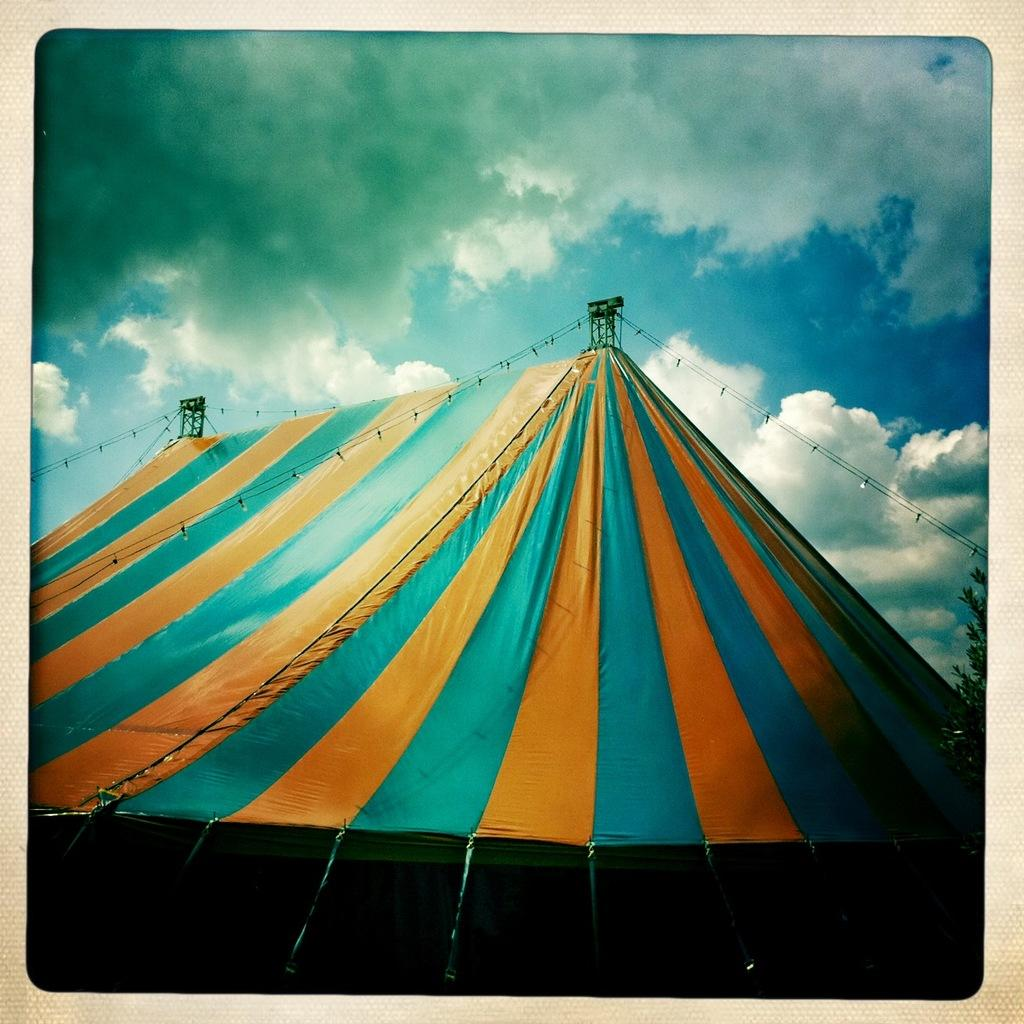What structure can be seen in the image? There is a tent in the image. What is located on the right side of the image? There is a tree on the right side of the image. What can be seen in the sky in the background of the image? There are clouds in the sky in the background of the image. Is there a jail visible in the image? No, there is no jail present in the image. Can you see a family gathering around the tent in the image? There is no information about a family or any gathering in the image. 